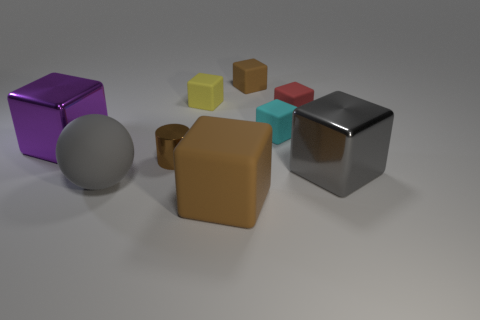Are there more shiny cylinders that are behind the yellow block than tiny brown rubber things on the right side of the large brown object?
Your answer should be compact. No. What size is the cyan cube?
Your answer should be compact. Small. There is a small matte thing left of the small brown rubber block; what is its shape?
Make the answer very short. Cube. Is the big brown rubber object the same shape as the brown shiny thing?
Ensure brevity in your answer.  No. Are there an equal number of tiny brown things in front of the tiny red thing and gray metal spheres?
Offer a very short reply. No. The tiny yellow object has what shape?
Keep it short and to the point. Cube. Is there anything else that has the same color as the cylinder?
Ensure brevity in your answer.  Yes. Does the brown cube that is behind the metallic cylinder have the same size as the metallic cylinder that is behind the large gray rubber sphere?
Offer a terse response. Yes. There is a large gray thing to the left of the brown matte thing that is behind the red matte thing; what is its shape?
Provide a succinct answer. Sphere. There is a brown cylinder; is its size the same as the brown rubber object that is behind the yellow matte thing?
Your response must be concise. Yes. 